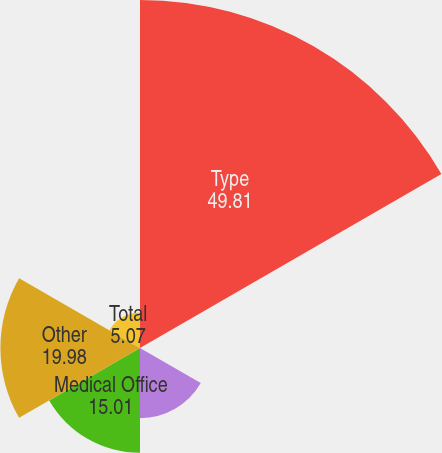<chart> <loc_0><loc_0><loc_500><loc_500><pie_chart><fcel>Type<fcel>Industrial<fcel>Office<fcel>Medical Office<fcel>Other<fcel>Total<nl><fcel>49.81%<fcel>0.1%<fcel>10.04%<fcel>15.01%<fcel>19.98%<fcel>5.07%<nl></chart> 